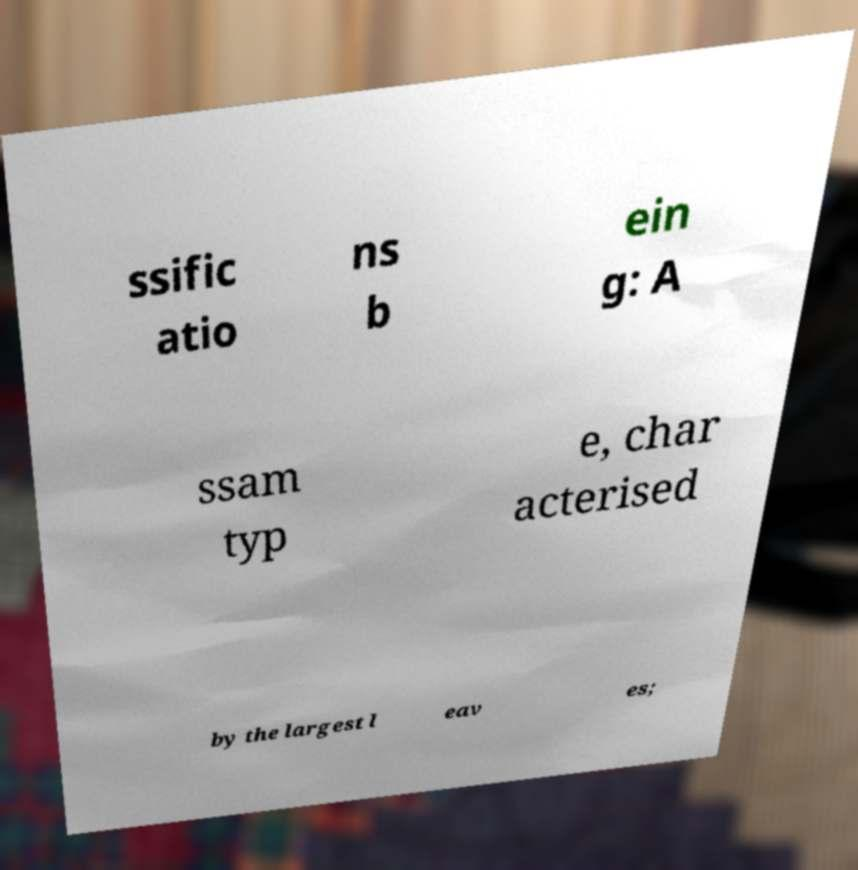Please read and relay the text visible in this image. What does it say? ssific atio ns b ein g: A ssam typ e, char acterised by the largest l eav es; 